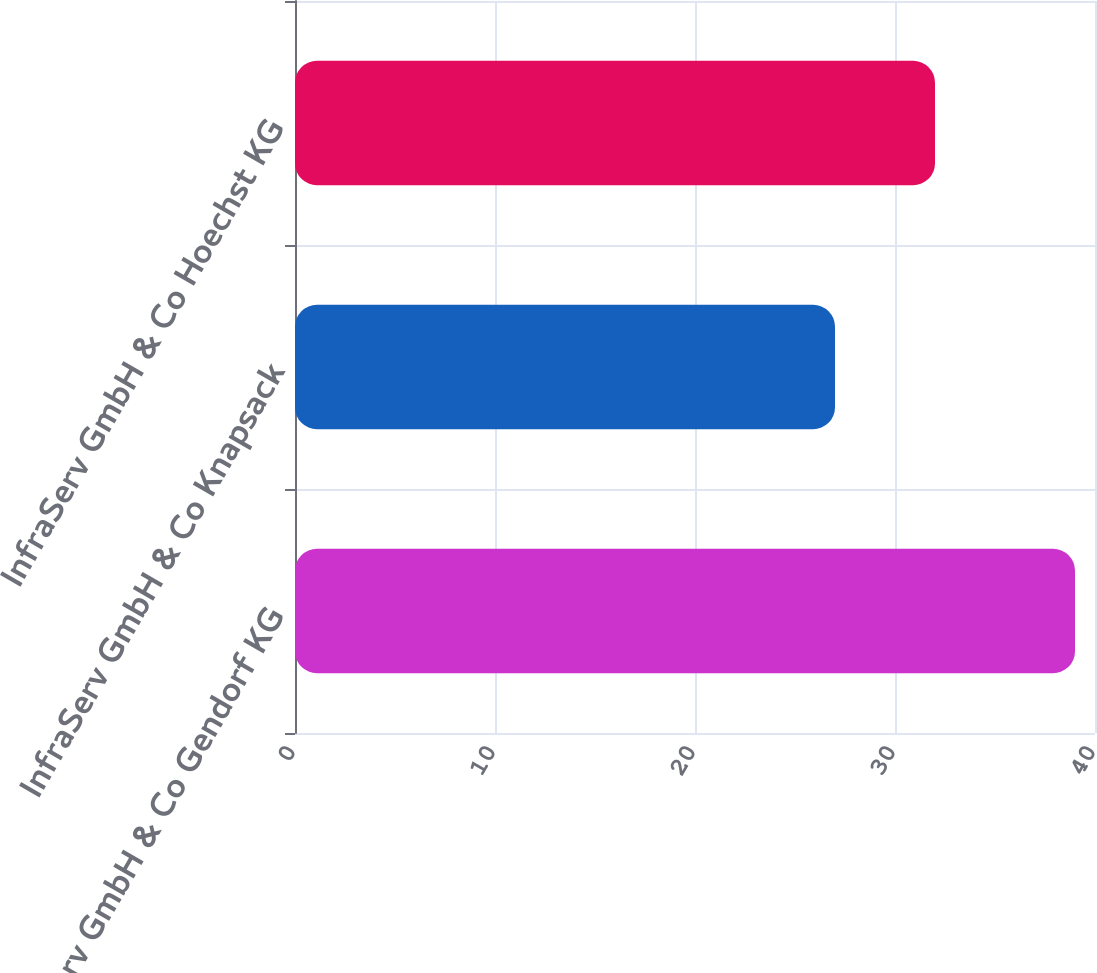<chart> <loc_0><loc_0><loc_500><loc_500><bar_chart><fcel>InfraServ GmbH & Co Gendorf KG<fcel>InfraServ GmbH & Co Knapsack<fcel>InfraServ GmbH & Co Hoechst KG<nl><fcel>39<fcel>27<fcel>32<nl></chart> 